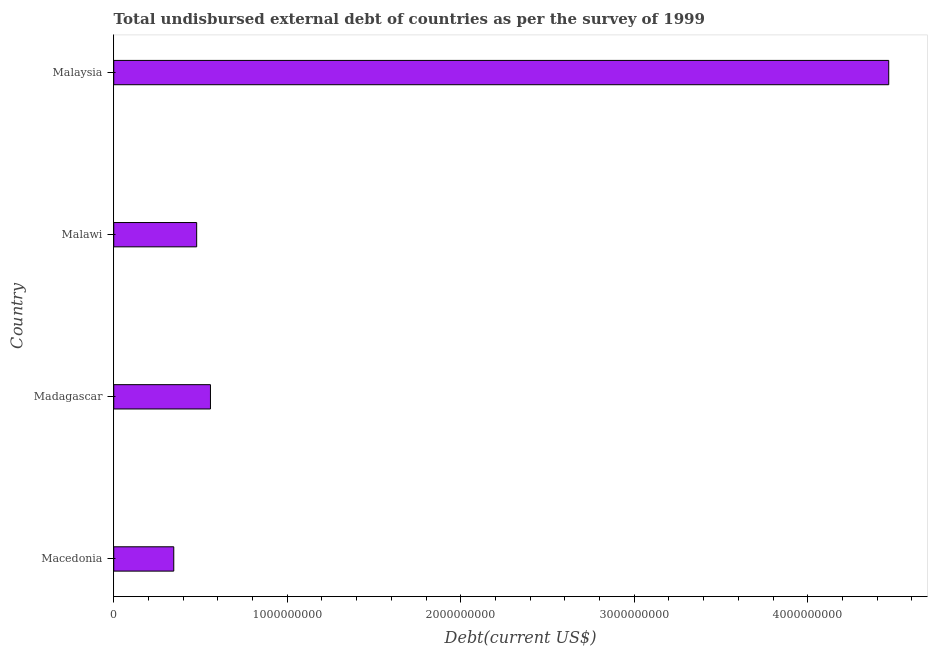Does the graph contain any zero values?
Offer a very short reply. No. What is the title of the graph?
Keep it short and to the point. Total undisbursed external debt of countries as per the survey of 1999. What is the label or title of the X-axis?
Keep it short and to the point. Debt(current US$). What is the total debt in Malaysia?
Provide a succinct answer. 4.47e+09. Across all countries, what is the maximum total debt?
Your answer should be very brief. 4.47e+09. Across all countries, what is the minimum total debt?
Your answer should be very brief. 3.46e+08. In which country was the total debt maximum?
Ensure brevity in your answer.  Malaysia. In which country was the total debt minimum?
Ensure brevity in your answer.  Macedonia. What is the sum of the total debt?
Provide a succinct answer. 5.85e+09. What is the difference between the total debt in Madagascar and Malaysia?
Your response must be concise. -3.91e+09. What is the average total debt per country?
Offer a very short reply. 1.46e+09. What is the median total debt?
Give a very brief answer. 5.18e+08. In how many countries, is the total debt greater than 2000000000 US$?
Provide a succinct answer. 1. What is the ratio of the total debt in Malawi to that in Malaysia?
Keep it short and to the point. 0.11. What is the difference between the highest and the second highest total debt?
Your answer should be very brief. 3.91e+09. What is the difference between the highest and the lowest total debt?
Your response must be concise. 4.12e+09. In how many countries, is the total debt greater than the average total debt taken over all countries?
Give a very brief answer. 1. Are all the bars in the graph horizontal?
Give a very brief answer. Yes. What is the Debt(current US$) of Macedonia?
Provide a succinct answer. 3.46e+08. What is the Debt(current US$) in Madagascar?
Give a very brief answer. 5.57e+08. What is the Debt(current US$) in Malawi?
Your answer should be compact. 4.78e+08. What is the Debt(current US$) in Malaysia?
Offer a terse response. 4.47e+09. What is the difference between the Debt(current US$) in Macedonia and Madagascar?
Your response must be concise. -2.11e+08. What is the difference between the Debt(current US$) in Macedonia and Malawi?
Offer a very short reply. -1.32e+08. What is the difference between the Debt(current US$) in Macedonia and Malaysia?
Make the answer very short. -4.12e+09. What is the difference between the Debt(current US$) in Madagascar and Malawi?
Keep it short and to the point. 7.94e+07. What is the difference between the Debt(current US$) in Madagascar and Malaysia?
Ensure brevity in your answer.  -3.91e+09. What is the difference between the Debt(current US$) in Malawi and Malaysia?
Offer a terse response. -3.99e+09. What is the ratio of the Debt(current US$) in Macedonia to that in Madagascar?
Make the answer very short. 0.62. What is the ratio of the Debt(current US$) in Macedonia to that in Malawi?
Provide a succinct answer. 0.72. What is the ratio of the Debt(current US$) in Macedonia to that in Malaysia?
Provide a short and direct response. 0.08. What is the ratio of the Debt(current US$) in Madagascar to that in Malawi?
Offer a terse response. 1.17. What is the ratio of the Debt(current US$) in Malawi to that in Malaysia?
Provide a short and direct response. 0.11. 